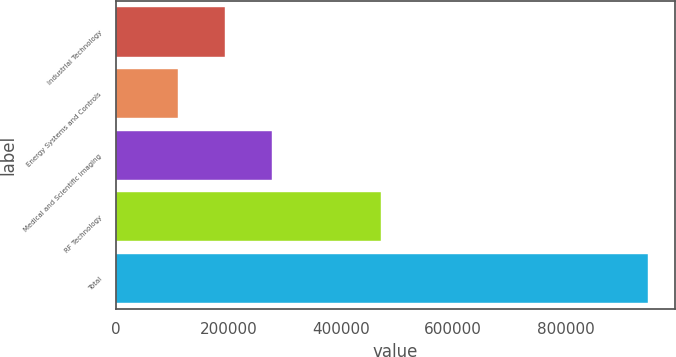<chart> <loc_0><loc_0><loc_500><loc_500><bar_chart><fcel>Industrial Technology<fcel>Energy Systems and Controls<fcel>Medical and Scientific Imaging<fcel>RF Technology<fcel>Total<nl><fcel>193618<fcel>109885<fcel>277351<fcel>471185<fcel>947217<nl></chart> 